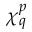<formula> <loc_0><loc_0><loc_500><loc_500>\chi _ { q } ^ { p }</formula> 